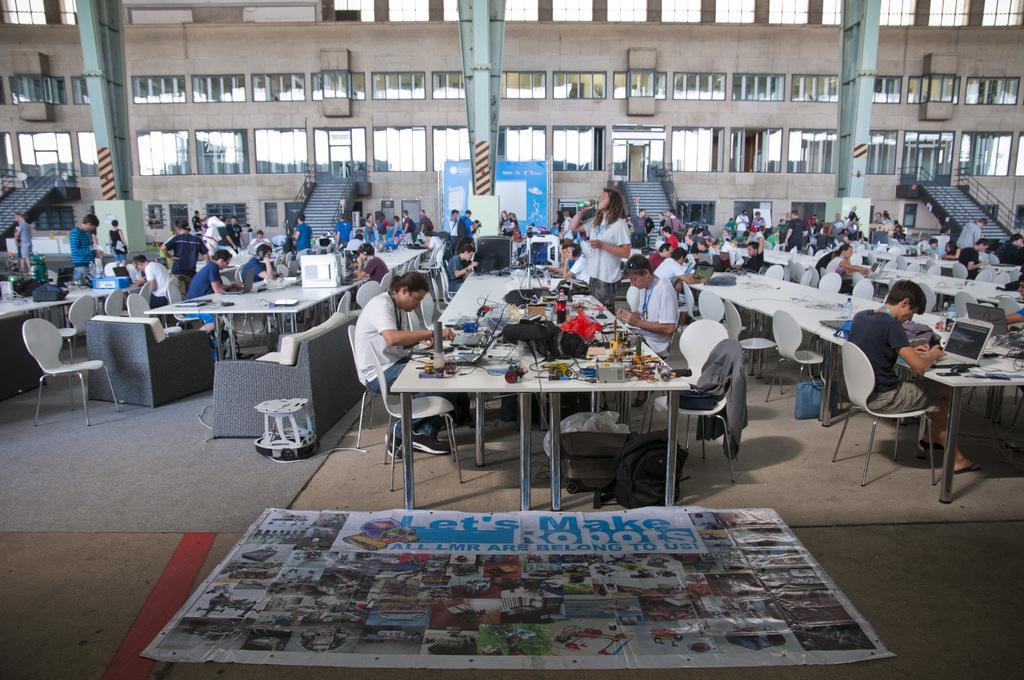Describe this image in one or two sentences. Most of the persons are sitting on a chair. In-front of this person there are tables, on tables there are things. Far there are steps. This is a building with window. On floor there is a poster. Under the table there is a bag and luggage. On this chair there is a jacket. This person is sitting in-front of laptop. 